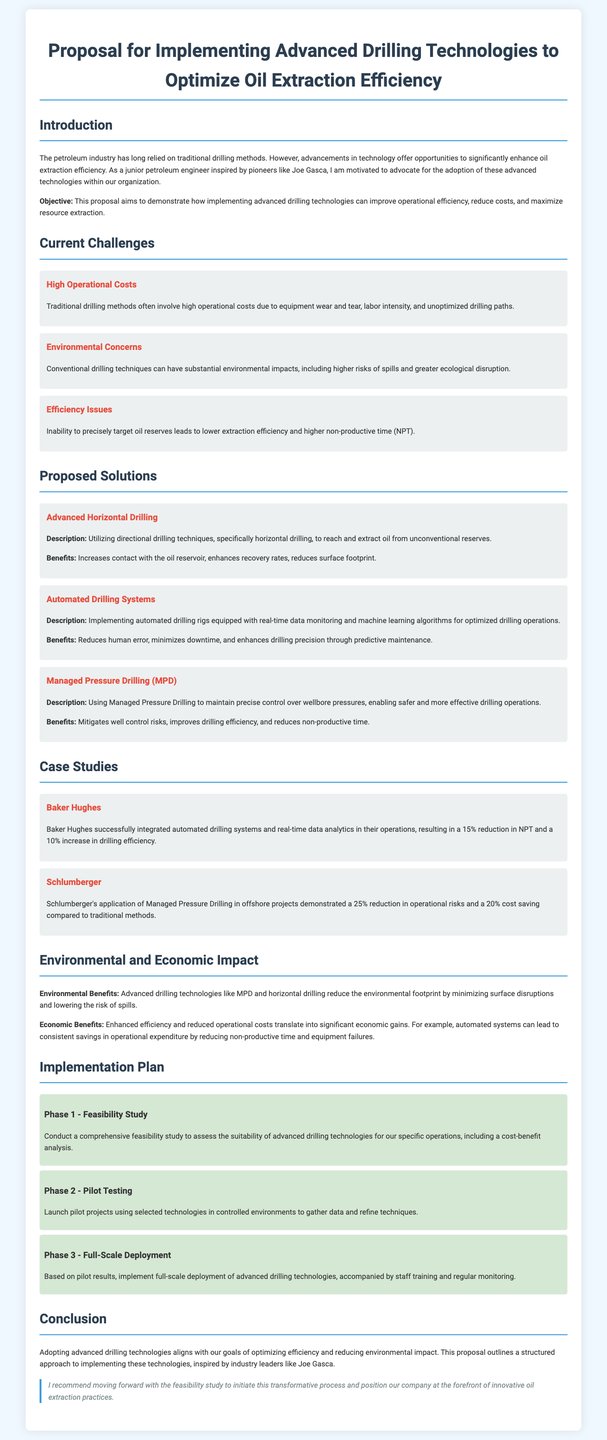what is the main objective of the proposal? The objective is to demonstrate how implementing advanced drilling technologies can improve operational efficiency, reduce costs, and maximize resource extraction.
Answer: improve operational efficiency, reduce costs, and maximize resource extraction which company successfully integrated automated drilling systems? The document mentions Baker Hughes as the company that integrated automated drilling systems.
Answer: Baker Hughes what is one benefit of advanced horizontal drilling? The benefit of advanced horizontal drilling includes increasing contact with the oil reservoir.
Answer: increases contact with the oil reservoir how many phases are there in the implementation plan? The implementation plan consists of three phases as outlined in the document.
Answer: three what is one environmental benefit of advanced drilling technologies? According to the document, advanced drilling technologies reduce the environmental footprint by minimizing surface disruptions.
Answer: minimizing surface disruptions what percentage reduction in NPT did Baker Hughes achieve? Baker Hughes achieved a 15% reduction in non-productive time (NPT) as stated in the case study.
Answer: 15% what is the first phase of the implementation plan? The first phase is conducting a comprehensive feasibility study to assess advanced drilling technologies.
Answer: Feasibility Study which drilling technique helps maintain precise control over wellbore pressures? Managed Pressure Drilling (MPD) is the technique mentioned that maintains precise control over wellbore pressures.
Answer: Managed Pressure Drilling (MPD) 